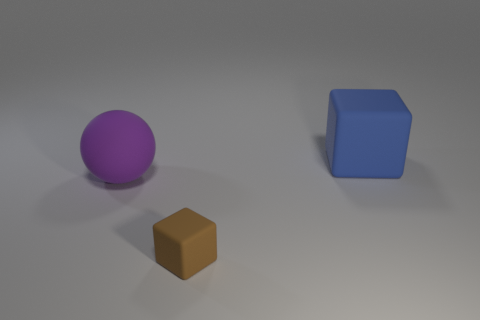Can you describe the colors and the lighting in the scene? Certainly! The image presents a simplistic scene with soft, diffuse lighting, creating a gentle shadow underneath the objects. The three objects are clearly distinguishable by their colors: one is purple, another blue, and the third a shade of brown. This muted color palette gives the scene a calm and tranquil vibe. 